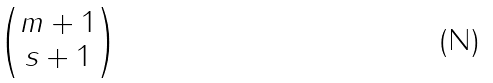<formula> <loc_0><loc_0><loc_500><loc_500>\begin{pmatrix} m + 1 \\ s + 1 \end{pmatrix}</formula> 